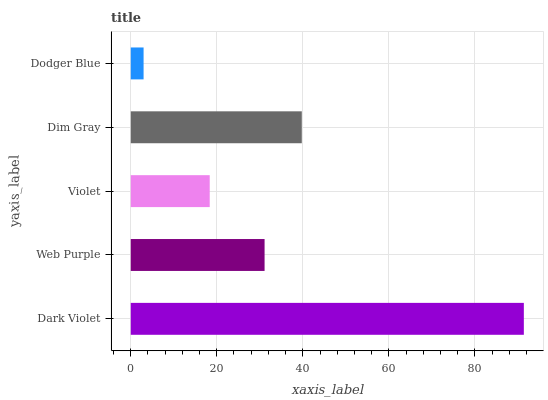Is Dodger Blue the minimum?
Answer yes or no. Yes. Is Dark Violet the maximum?
Answer yes or no. Yes. Is Web Purple the minimum?
Answer yes or no. No. Is Web Purple the maximum?
Answer yes or no. No. Is Dark Violet greater than Web Purple?
Answer yes or no. Yes. Is Web Purple less than Dark Violet?
Answer yes or no. Yes. Is Web Purple greater than Dark Violet?
Answer yes or no. No. Is Dark Violet less than Web Purple?
Answer yes or no. No. Is Web Purple the high median?
Answer yes or no. Yes. Is Web Purple the low median?
Answer yes or no. Yes. Is Dodger Blue the high median?
Answer yes or no. No. Is Dodger Blue the low median?
Answer yes or no. No. 